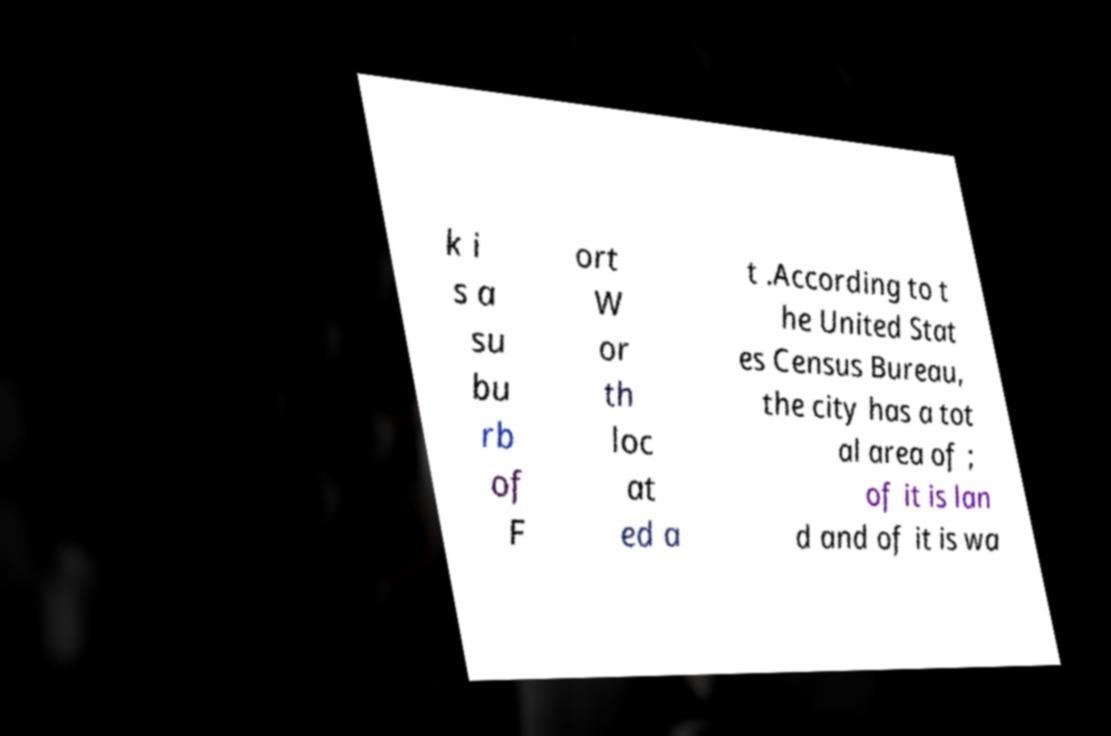Could you assist in decoding the text presented in this image and type it out clearly? k i s a su bu rb of F ort W or th loc at ed a t .According to t he United Stat es Census Bureau, the city has a tot al area of ; of it is lan d and of it is wa 